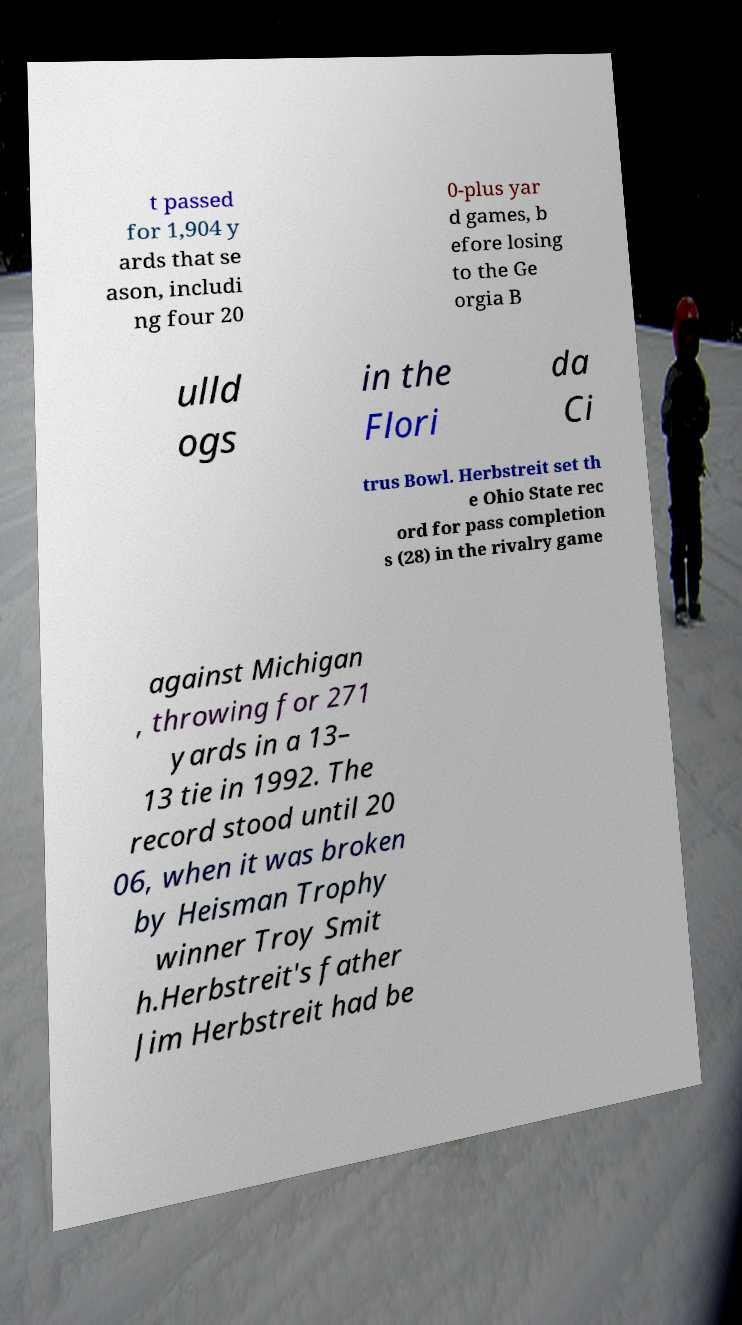I need the written content from this picture converted into text. Can you do that? t passed for 1,904 y ards that se ason, includi ng four 20 0-plus yar d games, b efore losing to the Ge orgia B ulld ogs in the Flori da Ci trus Bowl. Herbstreit set th e Ohio State rec ord for pass completion s (28) in the rivalry game against Michigan , throwing for 271 yards in a 13– 13 tie in 1992. The record stood until 20 06, when it was broken by Heisman Trophy winner Troy Smit h.Herbstreit's father Jim Herbstreit had be 